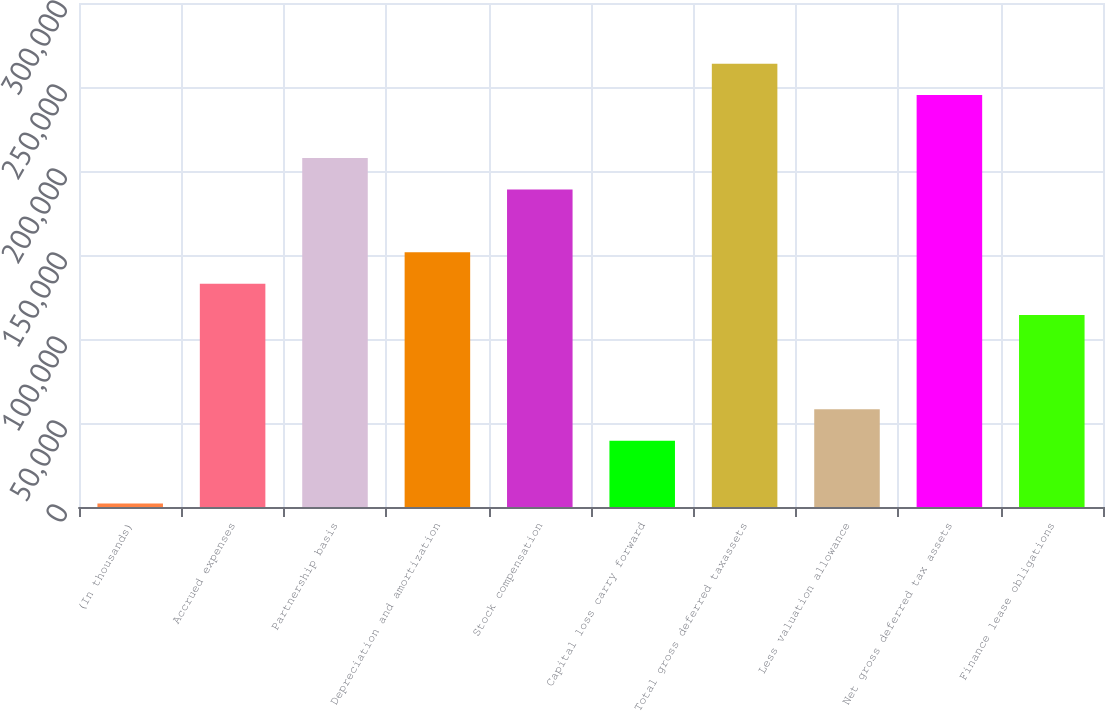Convert chart to OTSL. <chart><loc_0><loc_0><loc_500><loc_500><bar_chart><fcel>(In thousands)<fcel>Accrued expenses<fcel>Partnership basis<fcel>Depreciation and amortization<fcel>Stock compensation<fcel>Capital loss carry forward<fcel>Total gross deferred taxassets<fcel>Less valuation allowance<fcel>Net gross deferred tax assets<fcel>Finance lease obligations<nl><fcel>2012<fcel>132944<fcel>207762<fcel>151648<fcel>189057<fcel>39421<fcel>263875<fcel>58125.5<fcel>245170<fcel>114239<nl></chart> 